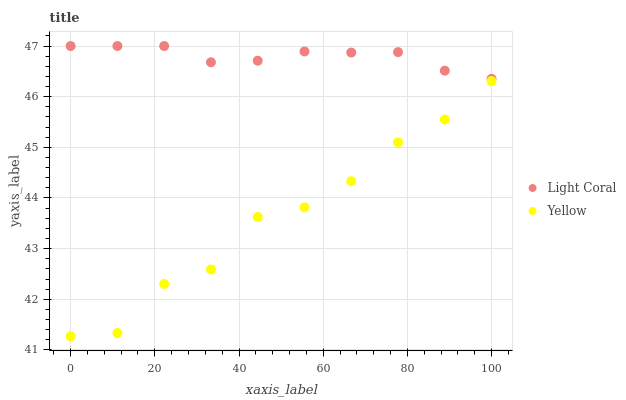Does Yellow have the minimum area under the curve?
Answer yes or no. Yes. Does Light Coral have the maximum area under the curve?
Answer yes or no. Yes. Does Yellow have the maximum area under the curve?
Answer yes or no. No. Is Light Coral the smoothest?
Answer yes or no. Yes. Is Yellow the roughest?
Answer yes or no. Yes. Is Yellow the smoothest?
Answer yes or no. No. Does Yellow have the lowest value?
Answer yes or no. Yes. Does Light Coral have the highest value?
Answer yes or no. Yes. Does Yellow have the highest value?
Answer yes or no. No. Is Yellow less than Light Coral?
Answer yes or no. Yes. Is Light Coral greater than Yellow?
Answer yes or no. Yes. Does Yellow intersect Light Coral?
Answer yes or no. No. 